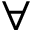<formula> <loc_0><loc_0><loc_500><loc_500>\forall</formula> 